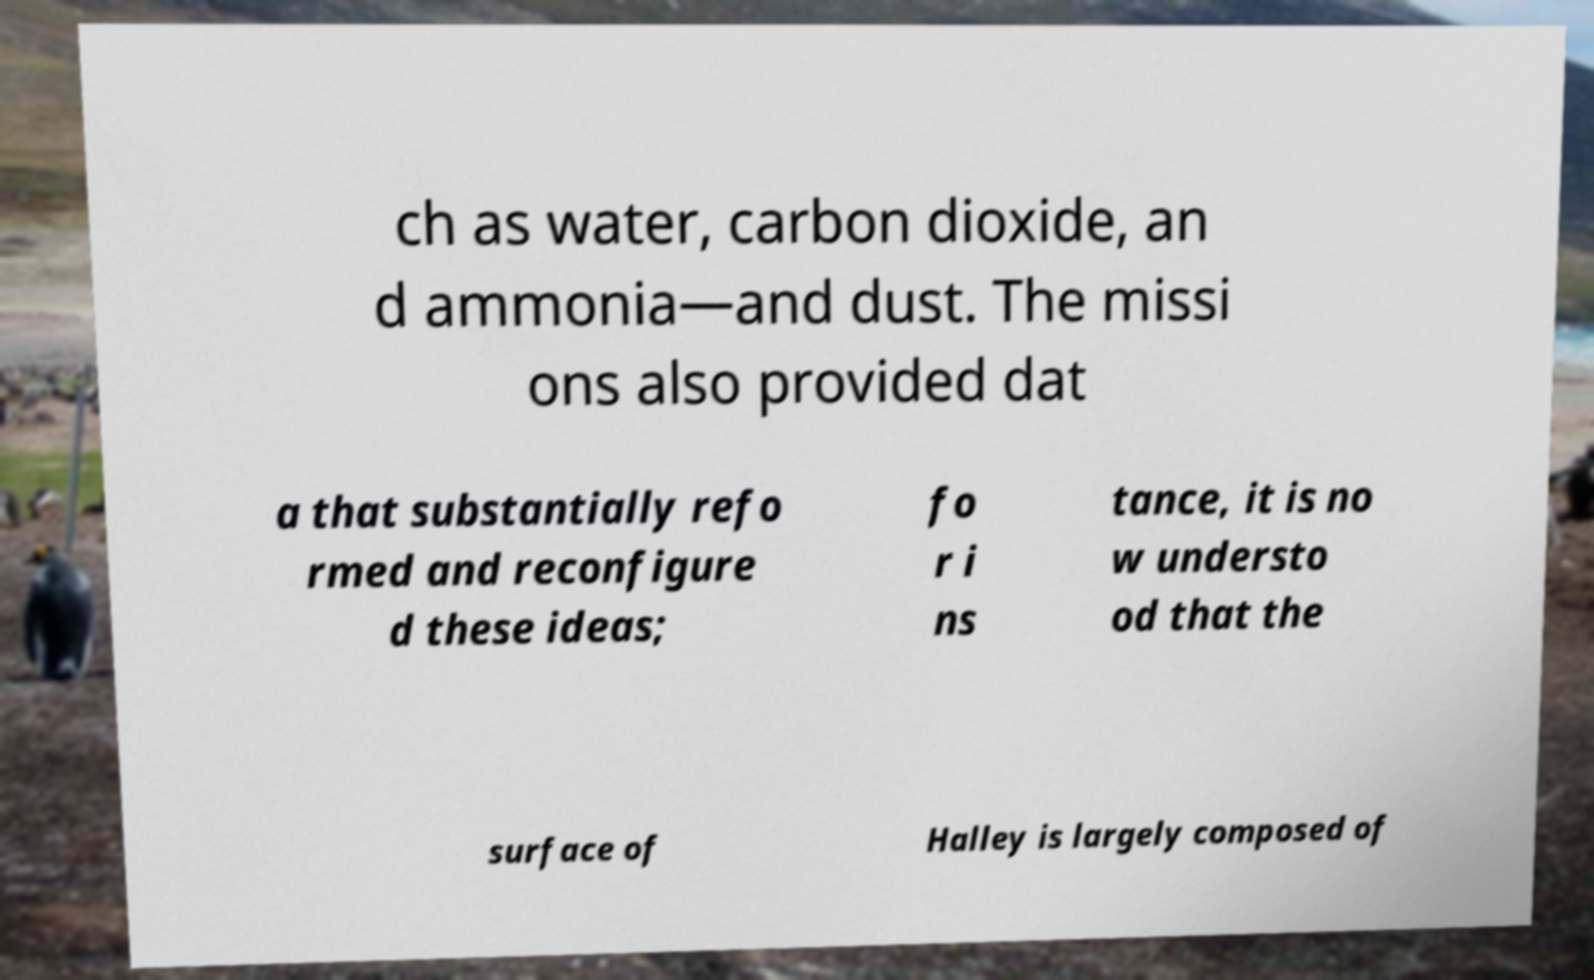Please read and relay the text visible in this image. What does it say? ch as water, carbon dioxide, an d ammonia—and dust. The missi ons also provided dat a that substantially refo rmed and reconfigure d these ideas; fo r i ns tance, it is no w understo od that the surface of Halley is largely composed of 